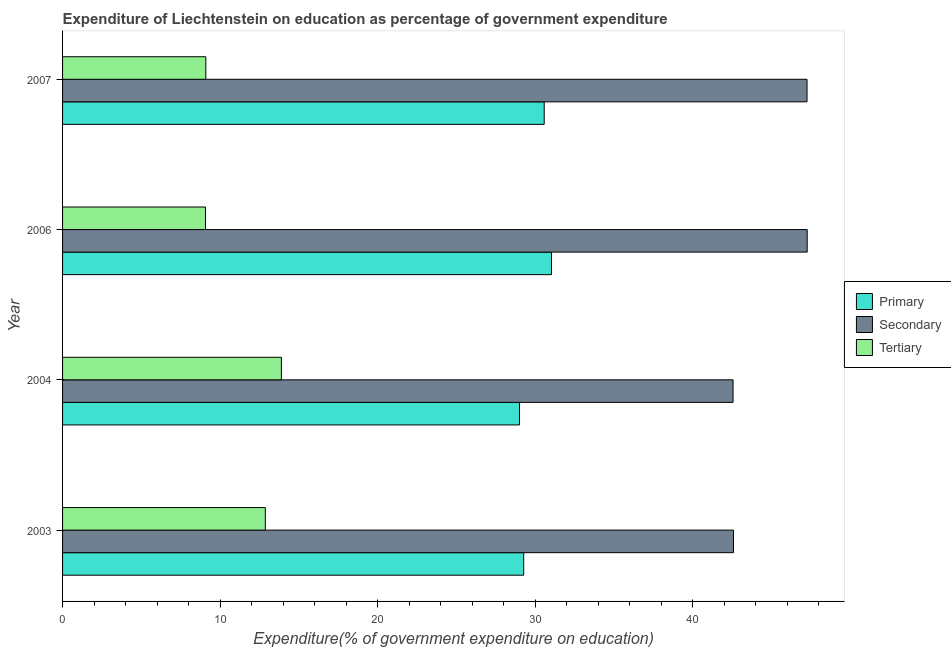How many different coloured bars are there?
Ensure brevity in your answer.  3. How many groups of bars are there?
Ensure brevity in your answer.  4. Are the number of bars per tick equal to the number of legend labels?
Provide a succinct answer. Yes. Are the number of bars on each tick of the Y-axis equal?
Provide a short and direct response. Yes. What is the expenditure on primary education in 2004?
Keep it short and to the point. 29. Across all years, what is the maximum expenditure on tertiary education?
Make the answer very short. 13.89. Across all years, what is the minimum expenditure on secondary education?
Make the answer very short. 42.55. In which year was the expenditure on primary education maximum?
Provide a succinct answer. 2006. In which year was the expenditure on tertiary education minimum?
Your answer should be very brief. 2006. What is the total expenditure on tertiary education in the graph?
Keep it short and to the point. 44.92. What is the difference between the expenditure on tertiary education in 2003 and that in 2007?
Your response must be concise. 3.78. What is the difference between the expenditure on secondary education in 2006 and the expenditure on primary education in 2004?
Your answer should be compact. 18.26. What is the average expenditure on primary education per year?
Make the answer very short. 29.97. In the year 2004, what is the difference between the expenditure on tertiary education and expenditure on secondary education?
Your answer should be compact. -28.67. In how many years, is the expenditure on tertiary education greater than 2 %?
Offer a very short reply. 4. What is the ratio of the expenditure on primary education in 2003 to that in 2004?
Provide a short and direct response. 1.01. Is the expenditure on tertiary education in 2004 less than that in 2007?
Give a very brief answer. No. What is the difference between the highest and the lowest expenditure on tertiary education?
Offer a terse response. 4.82. In how many years, is the expenditure on primary education greater than the average expenditure on primary education taken over all years?
Your answer should be compact. 2. What does the 2nd bar from the top in 2007 represents?
Your answer should be compact. Secondary. What does the 3rd bar from the bottom in 2006 represents?
Your answer should be compact. Tertiary. Is it the case that in every year, the sum of the expenditure on primary education and expenditure on secondary education is greater than the expenditure on tertiary education?
Your response must be concise. Yes. How many bars are there?
Your answer should be compact. 12. Are all the bars in the graph horizontal?
Offer a very short reply. Yes. How many years are there in the graph?
Give a very brief answer. 4. What is the difference between two consecutive major ticks on the X-axis?
Your response must be concise. 10. Are the values on the major ticks of X-axis written in scientific E-notation?
Give a very brief answer. No. Does the graph contain any zero values?
Give a very brief answer. No. Does the graph contain grids?
Your answer should be compact. No. How are the legend labels stacked?
Make the answer very short. Vertical. What is the title of the graph?
Offer a very short reply. Expenditure of Liechtenstein on education as percentage of government expenditure. What is the label or title of the X-axis?
Your answer should be very brief. Expenditure(% of government expenditure on education). What is the Expenditure(% of government expenditure on education) of Primary in 2003?
Keep it short and to the point. 29.27. What is the Expenditure(% of government expenditure on education) of Secondary in 2003?
Your response must be concise. 42.58. What is the Expenditure(% of government expenditure on education) in Tertiary in 2003?
Keep it short and to the point. 12.87. What is the Expenditure(% of government expenditure on education) in Primary in 2004?
Your answer should be very brief. 29. What is the Expenditure(% of government expenditure on education) in Secondary in 2004?
Offer a terse response. 42.55. What is the Expenditure(% of government expenditure on education) in Tertiary in 2004?
Provide a succinct answer. 13.89. What is the Expenditure(% of government expenditure on education) of Primary in 2006?
Your answer should be compact. 31.03. What is the Expenditure(% of government expenditure on education) in Secondary in 2006?
Offer a terse response. 47.26. What is the Expenditure(% of government expenditure on education) of Tertiary in 2006?
Ensure brevity in your answer.  9.07. What is the Expenditure(% of government expenditure on education) in Primary in 2007?
Give a very brief answer. 30.57. What is the Expenditure(% of government expenditure on education) of Secondary in 2007?
Provide a short and direct response. 47.25. What is the Expenditure(% of government expenditure on education) of Tertiary in 2007?
Your response must be concise. 9.09. Across all years, what is the maximum Expenditure(% of government expenditure on education) in Primary?
Provide a succinct answer. 31.03. Across all years, what is the maximum Expenditure(% of government expenditure on education) in Secondary?
Offer a very short reply. 47.26. Across all years, what is the maximum Expenditure(% of government expenditure on education) of Tertiary?
Your answer should be compact. 13.89. Across all years, what is the minimum Expenditure(% of government expenditure on education) in Primary?
Ensure brevity in your answer.  29. Across all years, what is the minimum Expenditure(% of government expenditure on education) of Secondary?
Provide a succinct answer. 42.55. Across all years, what is the minimum Expenditure(% of government expenditure on education) in Tertiary?
Give a very brief answer. 9.07. What is the total Expenditure(% of government expenditure on education) of Primary in the graph?
Ensure brevity in your answer.  119.87. What is the total Expenditure(% of government expenditure on education) in Secondary in the graph?
Offer a terse response. 179.64. What is the total Expenditure(% of government expenditure on education) in Tertiary in the graph?
Offer a very short reply. 44.92. What is the difference between the Expenditure(% of government expenditure on education) in Primary in 2003 and that in 2004?
Offer a terse response. 0.27. What is the difference between the Expenditure(% of government expenditure on education) in Secondary in 2003 and that in 2004?
Your response must be concise. 0.03. What is the difference between the Expenditure(% of government expenditure on education) of Tertiary in 2003 and that in 2004?
Provide a succinct answer. -1.02. What is the difference between the Expenditure(% of government expenditure on education) in Primary in 2003 and that in 2006?
Ensure brevity in your answer.  -1.76. What is the difference between the Expenditure(% of government expenditure on education) of Secondary in 2003 and that in 2006?
Offer a terse response. -4.68. What is the difference between the Expenditure(% of government expenditure on education) of Tertiary in 2003 and that in 2006?
Offer a terse response. 3.8. What is the difference between the Expenditure(% of government expenditure on education) of Primary in 2003 and that in 2007?
Offer a terse response. -1.3. What is the difference between the Expenditure(% of government expenditure on education) of Secondary in 2003 and that in 2007?
Your response must be concise. -4.67. What is the difference between the Expenditure(% of government expenditure on education) in Tertiary in 2003 and that in 2007?
Keep it short and to the point. 3.78. What is the difference between the Expenditure(% of government expenditure on education) in Primary in 2004 and that in 2006?
Keep it short and to the point. -2.03. What is the difference between the Expenditure(% of government expenditure on education) in Secondary in 2004 and that in 2006?
Your answer should be compact. -4.7. What is the difference between the Expenditure(% of government expenditure on education) of Tertiary in 2004 and that in 2006?
Your answer should be compact. 4.82. What is the difference between the Expenditure(% of government expenditure on education) in Primary in 2004 and that in 2007?
Provide a short and direct response. -1.57. What is the difference between the Expenditure(% of government expenditure on education) in Secondary in 2004 and that in 2007?
Provide a succinct answer. -4.69. What is the difference between the Expenditure(% of government expenditure on education) of Tertiary in 2004 and that in 2007?
Keep it short and to the point. 4.79. What is the difference between the Expenditure(% of government expenditure on education) in Primary in 2006 and that in 2007?
Give a very brief answer. 0.46. What is the difference between the Expenditure(% of government expenditure on education) in Secondary in 2006 and that in 2007?
Your answer should be very brief. 0.01. What is the difference between the Expenditure(% of government expenditure on education) in Tertiary in 2006 and that in 2007?
Your response must be concise. -0.02. What is the difference between the Expenditure(% of government expenditure on education) in Primary in 2003 and the Expenditure(% of government expenditure on education) in Secondary in 2004?
Make the answer very short. -13.29. What is the difference between the Expenditure(% of government expenditure on education) of Primary in 2003 and the Expenditure(% of government expenditure on education) of Tertiary in 2004?
Your answer should be compact. 15.38. What is the difference between the Expenditure(% of government expenditure on education) in Secondary in 2003 and the Expenditure(% of government expenditure on education) in Tertiary in 2004?
Your answer should be compact. 28.69. What is the difference between the Expenditure(% of government expenditure on education) in Primary in 2003 and the Expenditure(% of government expenditure on education) in Secondary in 2006?
Make the answer very short. -17.99. What is the difference between the Expenditure(% of government expenditure on education) of Primary in 2003 and the Expenditure(% of government expenditure on education) of Tertiary in 2006?
Your response must be concise. 20.2. What is the difference between the Expenditure(% of government expenditure on education) in Secondary in 2003 and the Expenditure(% of government expenditure on education) in Tertiary in 2006?
Keep it short and to the point. 33.51. What is the difference between the Expenditure(% of government expenditure on education) in Primary in 2003 and the Expenditure(% of government expenditure on education) in Secondary in 2007?
Keep it short and to the point. -17.98. What is the difference between the Expenditure(% of government expenditure on education) in Primary in 2003 and the Expenditure(% of government expenditure on education) in Tertiary in 2007?
Keep it short and to the point. 20.18. What is the difference between the Expenditure(% of government expenditure on education) of Secondary in 2003 and the Expenditure(% of government expenditure on education) of Tertiary in 2007?
Provide a succinct answer. 33.49. What is the difference between the Expenditure(% of government expenditure on education) of Primary in 2004 and the Expenditure(% of government expenditure on education) of Secondary in 2006?
Give a very brief answer. -18.26. What is the difference between the Expenditure(% of government expenditure on education) in Primary in 2004 and the Expenditure(% of government expenditure on education) in Tertiary in 2006?
Keep it short and to the point. 19.93. What is the difference between the Expenditure(% of government expenditure on education) of Secondary in 2004 and the Expenditure(% of government expenditure on education) of Tertiary in 2006?
Offer a terse response. 33.48. What is the difference between the Expenditure(% of government expenditure on education) of Primary in 2004 and the Expenditure(% of government expenditure on education) of Secondary in 2007?
Provide a succinct answer. -18.25. What is the difference between the Expenditure(% of government expenditure on education) in Primary in 2004 and the Expenditure(% of government expenditure on education) in Tertiary in 2007?
Your answer should be very brief. 19.91. What is the difference between the Expenditure(% of government expenditure on education) of Secondary in 2004 and the Expenditure(% of government expenditure on education) of Tertiary in 2007?
Your response must be concise. 33.46. What is the difference between the Expenditure(% of government expenditure on education) in Primary in 2006 and the Expenditure(% of government expenditure on education) in Secondary in 2007?
Give a very brief answer. -16.22. What is the difference between the Expenditure(% of government expenditure on education) in Primary in 2006 and the Expenditure(% of government expenditure on education) in Tertiary in 2007?
Your answer should be very brief. 21.94. What is the difference between the Expenditure(% of government expenditure on education) in Secondary in 2006 and the Expenditure(% of government expenditure on education) in Tertiary in 2007?
Ensure brevity in your answer.  38.17. What is the average Expenditure(% of government expenditure on education) of Primary per year?
Offer a terse response. 29.97. What is the average Expenditure(% of government expenditure on education) in Secondary per year?
Offer a terse response. 44.91. What is the average Expenditure(% of government expenditure on education) in Tertiary per year?
Ensure brevity in your answer.  11.23. In the year 2003, what is the difference between the Expenditure(% of government expenditure on education) of Primary and Expenditure(% of government expenditure on education) of Secondary?
Your response must be concise. -13.31. In the year 2003, what is the difference between the Expenditure(% of government expenditure on education) of Primary and Expenditure(% of government expenditure on education) of Tertiary?
Give a very brief answer. 16.4. In the year 2003, what is the difference between the Expenditure(% of government expenditure on education) of Secondary and Expenditure(% of government expenditure on education) of Tertiary?
Your answer should be compact. 29.71. In the year 2004, what is the difference between the Expenditure(% of government expenditure on education) in Primary and Expenditure(% of government expenditure on education) in Secondary?
Provide a short and direct response. -13.55. In the year 2004, what is the difference between the Expenditure(% of government expenditure on education) in Primary and Expenditure(% of government expenditure on education) in Tertiary?
Your answer should be very brief. 15.11. In the year 2004, what is the difference between the Expenditure(% of government expenditure on education) in Secondary and Expenditure(% of government expenditure on education) in Tertiary?
Give a very brief answer. 28.67. In the year 2006, what is the difference between the Expenditure(% of government expenditure on education) of Primary and Expenditure(% of government expenditure on education) of Secondary?
Your answer should be very brief. -16.23. In the year 2006, what is the difference between the Expenditure(% of government expenditure on education) in Primary and Expenditure(% of government expenditure on education) in Tertiary?
Offer a very short reply. 21.96. In the year 2006, what is the difference between the Expenditure(% of government expenditure on education) of Secondary and Expenditure(% of government expenditure on education) of Tertiary?
Make the answer very short. 38.19. In the year 2007, what is the difference between the Expenditure(% of government expenditure on education) of Primary and Expenditure(% of government expenditure on education) of Secondary?
Offer a terse response. -16.68. In the year 2007, what is the difference between the Expenditure(% of government expenditure on education) of Primary and Expenditure(% of government expenditure on education) of Tertiary?
Provide a short and direct response. 21.48. In the year 2007, what is the difference between the Expenditure(% of government expenditure on education) in Secondary and Expenditure(% of government expenditure on education) in Tertiary?
Provide a succinct answer. 38.16. What is the ratio of the Expenditure(% of government expenditure on education) in Primary in 2003 to that in 2004?
Provide a succinct answer. 1.01. What is the ratio of the Expenditure(% of government expenditure on education) of Secondary in 2003 to that in 2004?
Give a very brief answer. 1. What is the ratio of the Expenditure(% of government expenditure on education) in Tertiary in 2003 to that in 2004?
Make the answer very short. 0.93. What is the ratio of the Expenditure(% of government expenditure on education) in Primary in 2003 to that in 2006?
Make the answer very short. 0.94. What is the ratio of the Expenditure(% of government expenditure on education) of Secondary in 2003 to that in 2006?
Keep it short and to the point. 0.9. What is the ratio of the Expenditure(% of government expenditure on education) of Tertiary in 2003 to that in 2006?
Give a very brief answer. 1.42. What is the ratio of the Expenditure(% of government expenditure on education) of Primary in 2003 to that in 2007?
Keep it short and to the point. 0.96. What is the ratio of the Expenditure(% of government expenditure on education) of Secondary in 2003 to that in 2007?
Make the answer very short. 0.9. What is the ratio of the Expenditure(% of government expenditure on education) of Tertiary in 2003 to that in 2007?
Your answer should be very brief. 1.42. What is the ratio of the Expenditure(% of government expenditure on education) in Primary in 2004 to that in 2006?
Your answer should be very brief. 0.93. What is the ratio of the Expenditure(% of government expenditure on education) in Secondary in 2004 to that in 2006?
Ensure brevity in your answer.  0.9. What is the ratio of the Expenditure(% of government expenditure on education) of Tertiary in 2004 to that in 2006?
Offer a very short reply. 1.53. What is the ratio of the Expenditure(% of government expenditure on education) in Primary in 2004 to that in 2007?
Offer a very short reply. 0.95. What is the ratio of the Expenditure(% of government expenditure on education) in Secondary in 2004 to that in 2007?
Provide a succinct answer. 0.9. What is the ratio of the Expenditure(% of government expenditure on education) of Tertiary in 2004 to that in 2007?
Provide a short and direct response. 1.53. What is the ratio of the Expenditure(% of government expenditure on education) of Primary in 2006 to that in 2007?
Your answer should be compact. 1.02. What is the ratio of the Expenditure(% of government expenditure on education) of Secondary in 2006 to that in 2007?
Make the answer very short. 1. What is the ratio of the Expenditure(% of government expenditure on education) in Tertiary in 2006 to that in 2007?
Your answer should be compact. 1. What is the difference between the highest and the second highest Expenditure(% of government expenditure on education) in Primary?
Ensure brevity in your answer.  0.46. What is the difference between the highest and the second highest Expenditure(% of government expenditure on education) of Secondary?
Ensure brevity in your answer.  0.01. What is the difference between the highest and the second highest Expenditure(% of government expenditure on education) in Tertiary?
Keep it short and to the point. 1.02. What is the difference between the highest and the lowest Expenditure(% of government expenditure on education) in Primary?
Your response must be concise. 2.03. What is the difference between the highest and the lowest Expenditure(% of government expenditure on education) in Secondary?
Provide a succinct answer. 4.7. What is the difference between the highest and the lowest Expenditure(% of government expenditure on education) of Tertiary?
Offer a terse response. 4.82. 